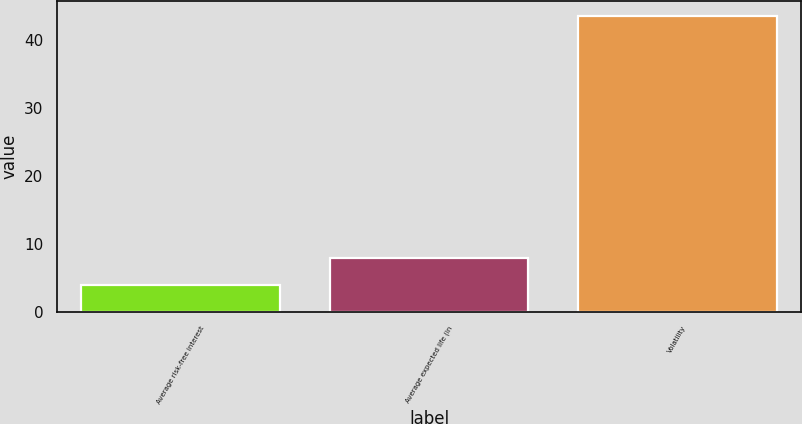Convert chart. <chart><loc_0><loc_0><loc_500><loc_500><bar_chart><fcel>Average risk-free interest<fcel>Average expected life (in<fcel>Volatility<nl><fcel>3.9<fcel>7.87<fcel>43.6<nl></chart> 